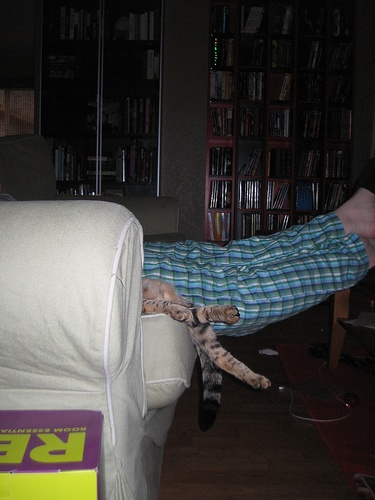Describe the objects in this image and their specific colors. I can see book in black, gray, darkgray, and blue tones, couch in black, darkgray, lightgray, and gray tones, people in black, gray, and blue tones, cat in black and gray tones, and chair in black tones in this image. 